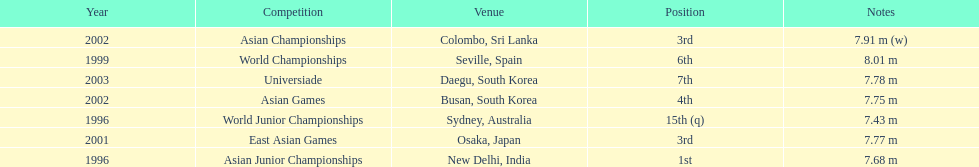70 m? 5. 